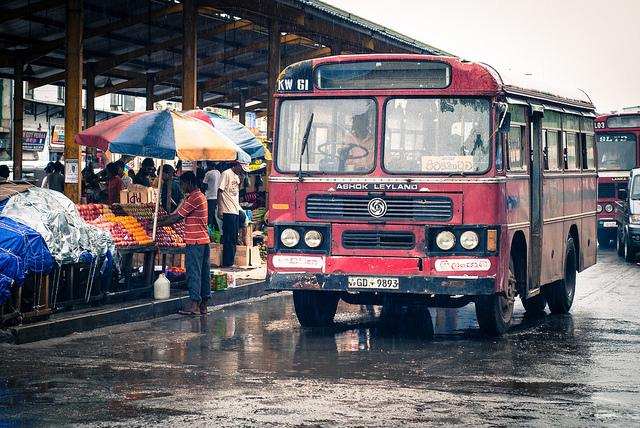What food can you buy as you get on the bus?

Choices:
A) bread
B) steak
C) fish
D) fruit fruit 